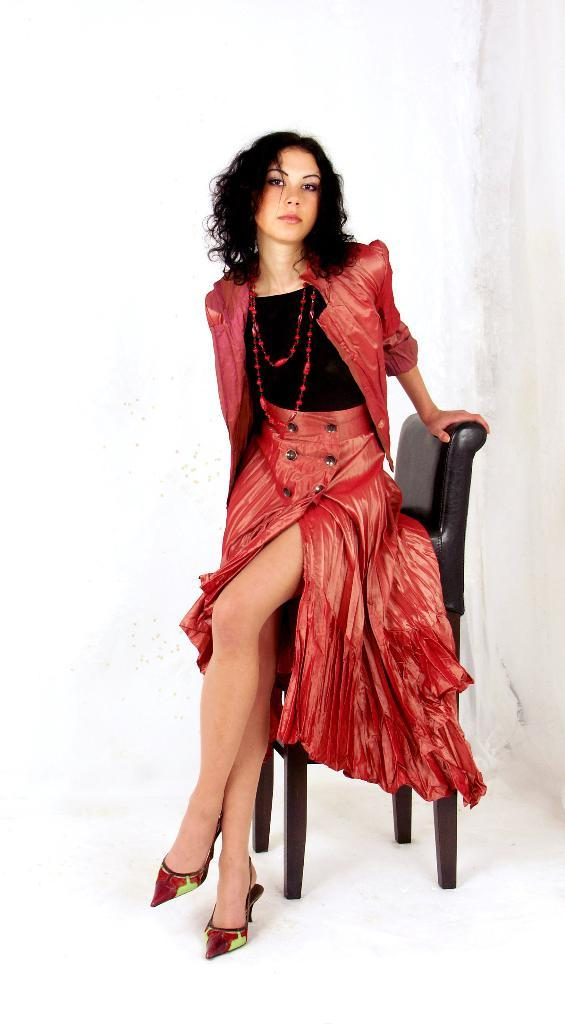Who is the main subject in the image? There is a woman in the image. What is the woman wearing? The woman is wearing a brown and black colored dress. What is the woman doing in the image? The woman is sitting on a chair. What color is the chair the woman is sitting on? The chair is black in color. What is the color of the background in the image? A: The background of the image is white. What type of honey is the woman eating in the image? There is no honey present in the image; the woman is sitting on a chair wearing a brown and black colored dress. What is the woman having for lunch in the image? There is no indication of lunch in the image; the woman is sitting on a chair wearing a brown and black colored dress. 